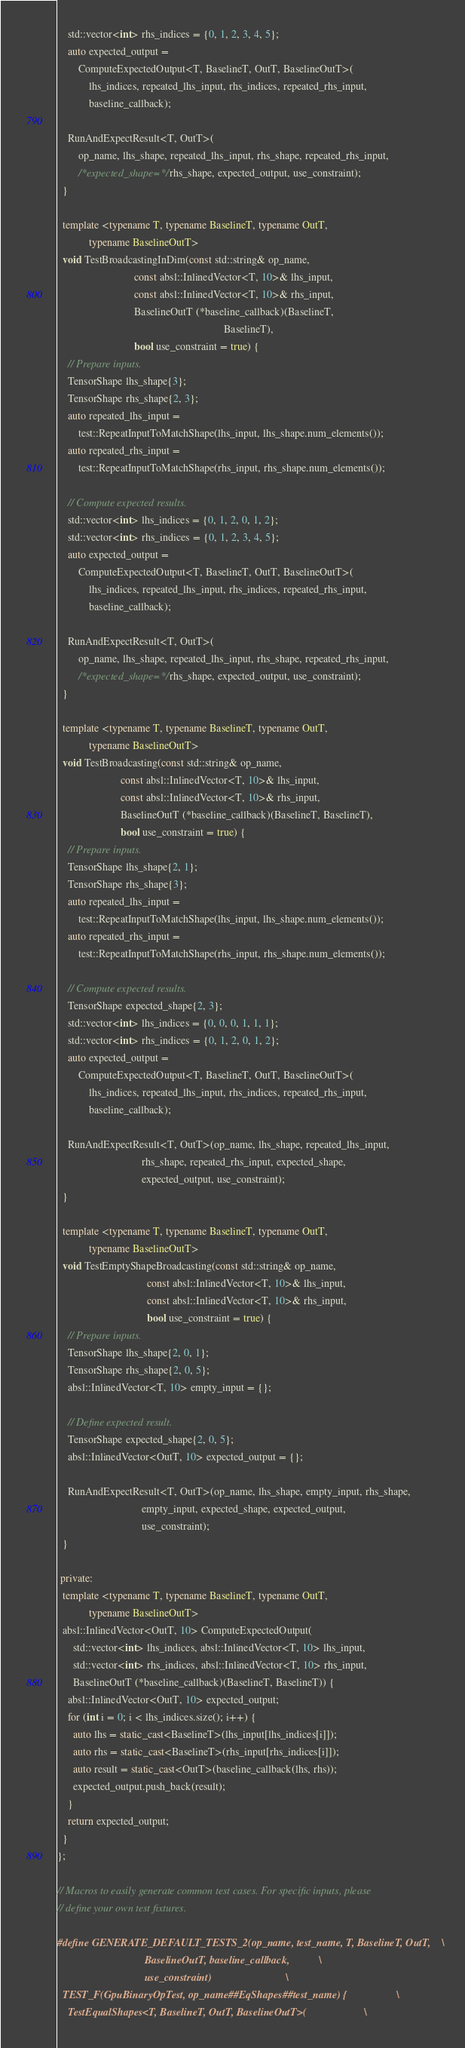<code> <loc_0><loc_0><loc_500><loc_500><_C++_>    std::vector<int> rhs_indices = {0, 1, 2, 3, 4, 5};
    auto expected_output =
        ComputeExpectedOutput<T, BaselineT, OutT, BaselineOutT>(
            lhs_indices, repeated_lhs_input, rhs_indices, repeated_rhs_input,
            baseline_callback);

    RunAndExpectResult<T, OutT>(
        op_name, lhs_shape, repeated_lhs_input, rhs_shape, repeated_rhs_input,
        /*expected_shape=*/rhs_shape, expected_output, use_constraint);
  }

  template <typename T, typename BaselineT, typename OutT,
            typename BaselineOutT>
  void TestBroadcastingInDim(const std::string& op_name,
                             const absl::InlinedVector<T, 10>& lhs_input,
                             const absl::InlinedVector<T, 10>& rhs_input,
                             BaselineOutT (*baseline_callback)(BaselineT,
                                                               BaselineT),
                             bool use_constraint = true) {
    // Prepare inputs.
    TensorShape lhs_shape{3};
    TensorShape rhs_shape{2, 3};
    auto repeated_lhs_input =
        test::RepeatInputToMatchShape(lhs_input, lhs_shape.num_elements());
    auto repeated_rhs_input =
        test::RepeatInputToMatchShape(rhs_input, rhs_shape.num_elements());

    // Compute expected results.
    std::vector<int> lhs_indices = {0, 1, 2, 0, 1, 2};
    std::vector<int> rhs_indices = {0, 1, 2, 3, 4, 5};
    auto expected_output =
        ComputeExpectedOutput<T, BaselineT, OutT, BaselineOutT>(
            lhs_indices, repeated_lhs_input, rhs_indices, repeated_rhs_input,
            baseline_callback);

    RunAndExpectResult<T, OutT>(
        op_name, lhs_shape, repeated_lhs_input, rhs_shape, repeated_rhs_input,
        /*expected_shape=*/rhs_shape, expected_output, use_constraint);
  }

  template <typename T, typename BaselineT, typename OutT,
            typename BaselineOutT>
  void TestBroadcasting(const std::string& op_name,
                        const absl::InlinedVector<T, 10>& lhs_input,
                        const absl::InlinedVector<T, 10>& rhs_input,
                        BaselineOutT (*baseline_callback)(BaselineT, BaselineT),
                        bool use_constraint = true) {
    // Prepare inputs.
    TensorShape lhs_shape{2, 1};
    TensorShape rhs_shape{3};
    auto repeated_lhs_input =
        test::RepeatInputToMatchShape(lhs_input, lhs_shape.num_elements());
    auto repeated_rhs_input =
        test::RepeatInputToMatchShape(rhs_input, rhs_shape.num_elements());

    // Compute expected results.
    TensorShape expected_shape{2, 3};
    std::vector<int> lhs_indices = {0, 0, 0, 1, 1, 1};
    std::vector<int> rhs_indices = {0, 1, 2, 0, 1, 2};
    auto expected_output =
        ComputeExpectedOutput<T, BaselineT, OutT, BaselineOutT>(
            lhs_indices, repeated_lhs_input, rhs_indices, repeated_rhs_input,
            baseline_callback);

    RunAndExpectResult<T, OutT>(op_name, lhs_shape, repeated_lhs_input,
                                rhs_shape, repeated_rhs_input, expected_shape,
                                expected_output, use_constraint);
  }

  template <typename T, typename BaselineT, typename OutT,
            typename BaselineOutT>
  void TestEmptyShapeBroadcasting(const std::string& op_name,
                                  const absl::InlinedVector<T, 10>& lhs_input,
                                  const absl::InlinedVector<T, 10>& rhs_input,
                                  bool use_constraint = true) {
    // Prepare inputs.
    TensorShape lhs_shape{2, 0, 1};
    TensorShape rhs_shape{2, 0, 5};
    absl::InlinedVector<T, 10> empty_input = {};

    // Define expected result.
    TensorShape expected_shape{2, 0, 5};
    absl::InlinedVector<OutT, 10> expected_output = {};

    RunAndExpectResult<T, OutT>(op_name, lhs_shape, empty_input, rhs_shape,
                                empty_input, expected_shape, expected_output,
                                use_constraint);
  }

 private:
  template <typename T, typename BaselineT, typename OutT,
            typename BaselineOutT>
  absl::InlinedVector<OutT, 10> ComputeExpectedOutput(
      std::vector<int> lhs_indices, absl::InlinedVector<T, 10> lhs_input,
      std::vector<int> rhs_indices, absl::InlinedVector<T, 10> rhs_input,
      BaselineOutT (*baseline_callback)(BaselineT, BaselineT)) {
    absl::InlinedVector<OutT, 10> expected_output;
    for (int i = 0; i < lhs_indices.size(); i++) {
      auto lhs = static_cast<BaselineT>(lhs_input[lhs_indices[i]]);
      auto rhs = static_cast<BaselineT>(rhs_input[rhs_indices[i]]);
      auto result = static_cast<OutT>(baseline_callback(lhs, rhs));
      expected_output.push_back(result);
    }
    return expected_output;
  }
};

// Macros to easily generate common test cases. For specific inputs, please
// define your own test fixtures.

#define GENERATE_DEFAULT_TESTS_2(op_name, test_name, T, BaselineT, OutT,    \
                                 BaselineOutT, baseline_callback,           \
                                 use_constraint)                            \
  TEST_F(GpuBinaryOpTest, op_name##EqShapes##test_name) {                   \
    TestEqualShapes<T, BaselineT, OutT, BaselineOutT>(                      \</code> 